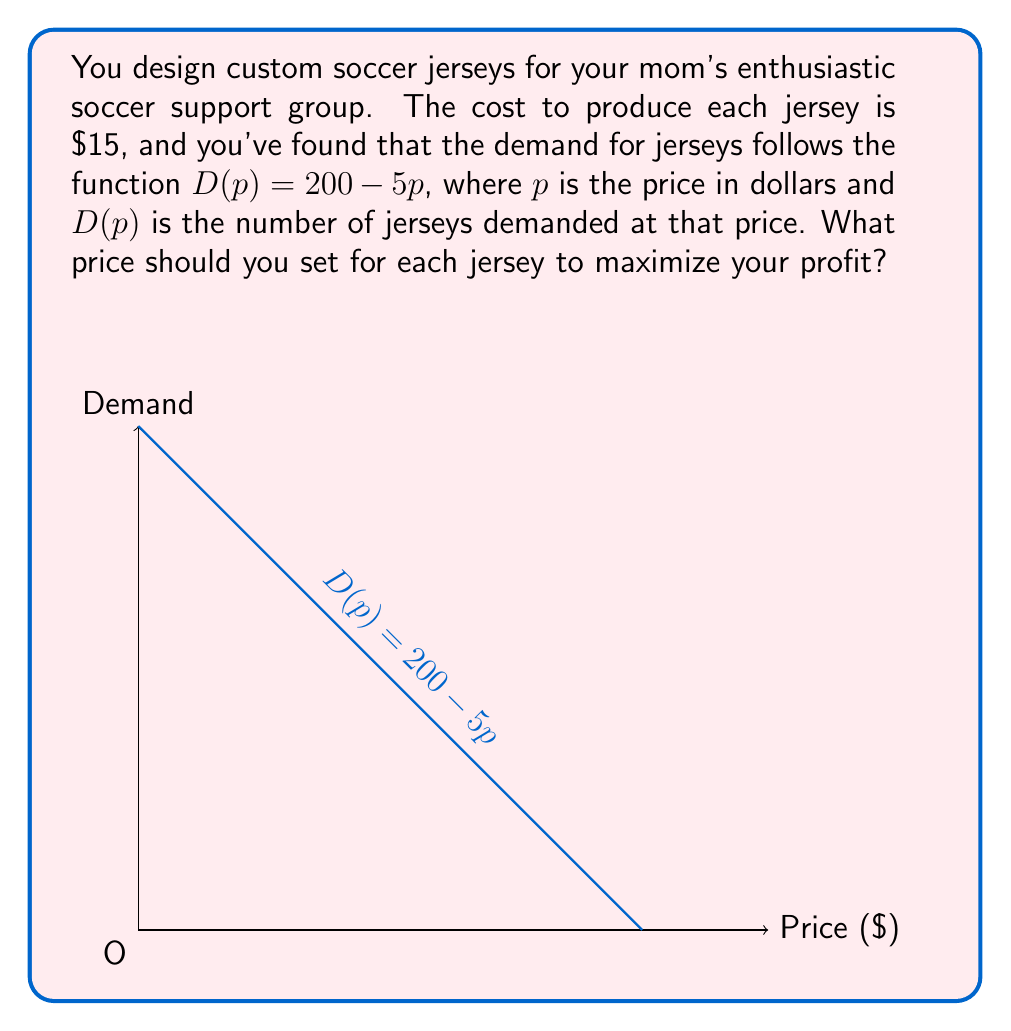Show me your answer to this math problem. Let's approach this step-by-step:

1) First, we need to set up our profit function. Profit is revenue minus cost:
   $$\text{Profit} = \text{Revenue} - \text{Cost}$$

2) Revenue is price times quantity sold:
   $$\text{Revenue} = p \cdot D(p) = p(200 - 5p) = 200p - 5p^2$$

3) Cost is the number of jerseys produced times the cost per jersey:
   $$\text{Cost} = 15 \cdot D(p) = 15(200 - 5p) = 3000 - 75p$$

4) Now we can write our profit function:
   $$\text{Profit} = (200p - 5p^2) - (3000 - 75p)$$
   $$\text{Profit} = 200p - 5p^2 - 3000 + 75p$$
   $$\text{Profit} = -5p^2 + 275p - 3000$$

5) To find the maximum profit, we need to find where the derivative of this function equals zero:
   $$\frac{d}{dp}(\text{Profit}) = -10p + 275 = 0$$

6) Solving this equation:
   $$-10p + 275 = 0$$
   $$-10p = -275$$
   $$p = 27.5$$

7) To confirm this is a maximum (not a minimum), we can check the second derivative:
   $$\frac{d^2}{dp^2}(\text{Profit}) = -10$$
   Since this is negative, we confirm that $p = 27.5$ gives a maximum.

8) Therefore, to maximize profit, you should set the price at $27.50 per jersey.
Answer: $27.50 